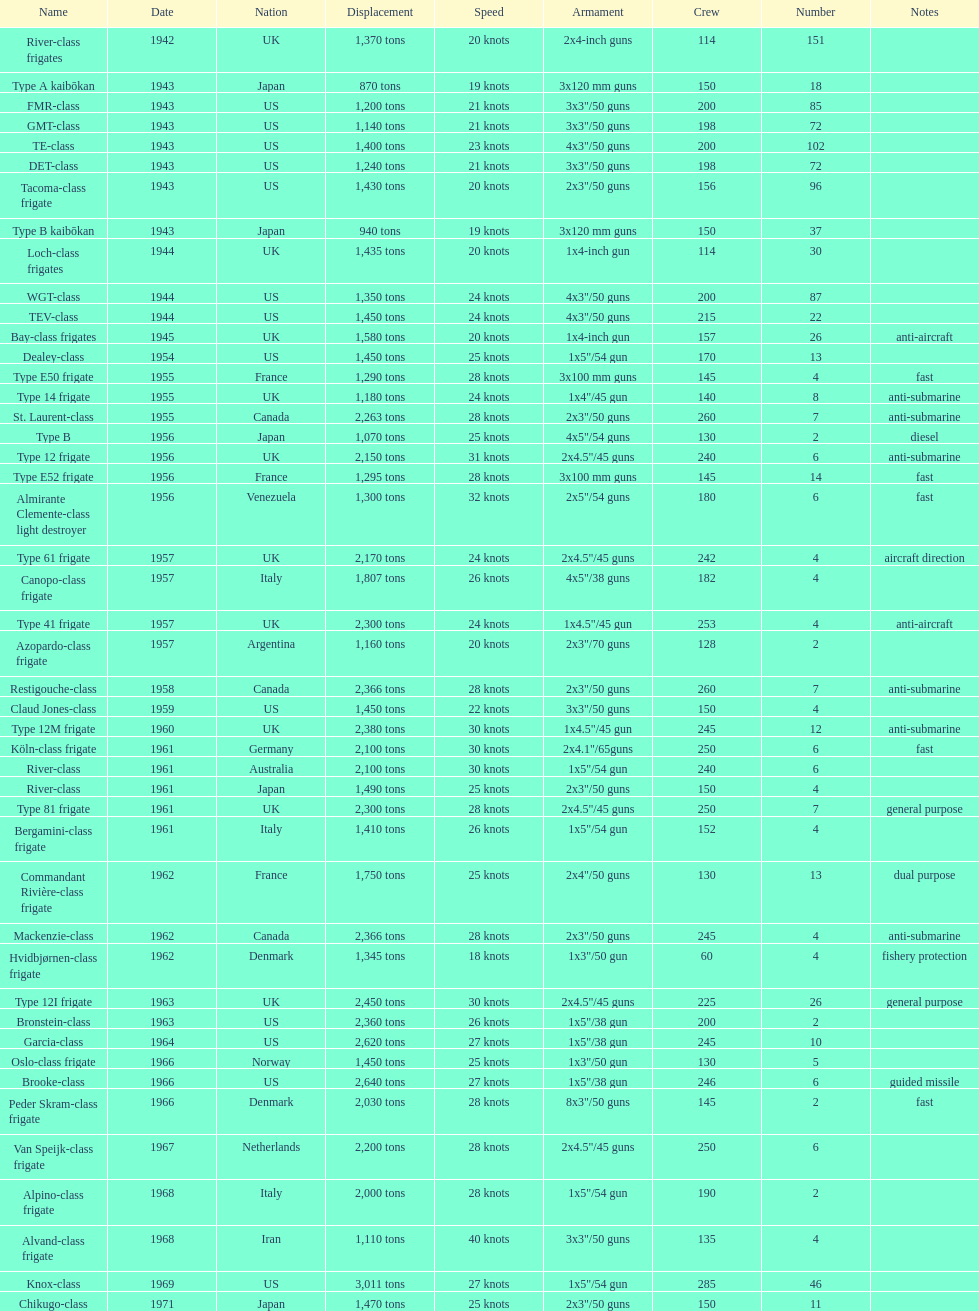What's the tonnage of displacement for type b? 940 tons. 